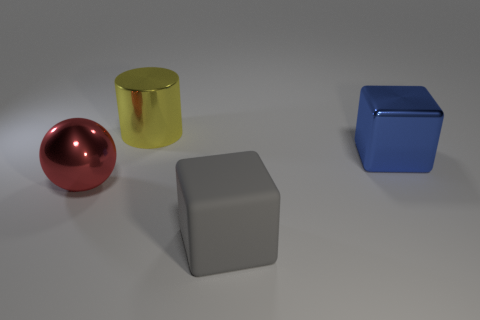Add 2 balls. How many objects exist? 6 Subtract all cylinders. How many objects are left? 3 Subtract all tiny cyan metallic blocks. Subtract all yellow cylinders. How many objects are left? 3 Add 2 large gray cubes. How many large gray cubes are left? 3 Add 3 big purple rubber things. How many big purple rubber things exist? 3 Subtract 0 brown blocks. How many objects are left? 4 